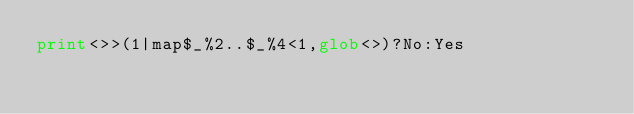Convert code to text. <code><loc_0><loc_0><loc_500><loc_500><_Perl_>print<>>(1|map$_%2..$_%4<1,glob<>)?No:Yes</code> 